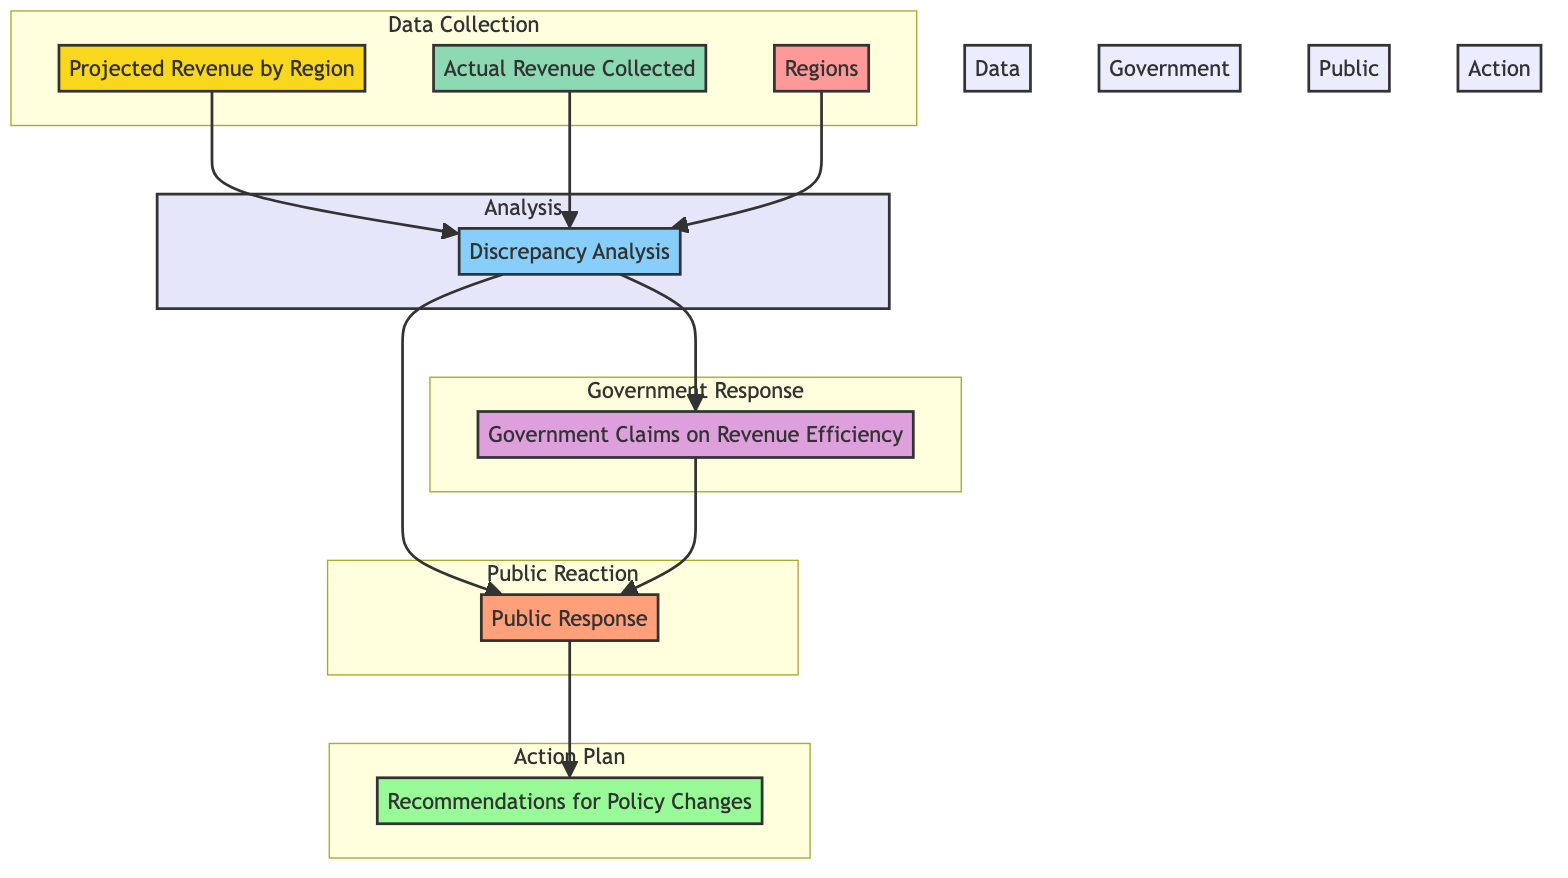What are the two types of revenue figures presented in the diagram? The diagram mentions "Projected Revenue by Region" and "Actual Revenue Collected." Both types provide information about tax revenue figures but are based on different timeframes—projected figures are estimates, while actual figures reflect what was collected after the fiscal year.
Answer: Projected Revenue by Region, Actual Revenue Collected How many regions are considered in the analysis of tax revenue? The diagram identifies that the "Regions" element is used in the revenue comparison without specifying the exact number. However, typically, there are four regions mentioned: Northeast, Southeast, Midwest, and West, comprising a general structure for regional analysis.
Answer: Four What is the main purpose of the Discrepancy Analysis process? The "Discrepancy Analysis" evaluates the differences between projected and actual revenues, highlighting inconsistencies that might indicate inefficiencies in revenue collection as claimed by the government.
Answer: Highlight inconsistencies Which element feeds into both "Government Claims on Revenue Efficiency" and "Public Response"? The "Discrepancy Analysis" feeds into both nodes because it scrutinizes the differences in revenue, prompting government claims about efficiency and influencing public response to any discrepancies found.
Answer: Discrepancy Analysis What does the "Public Response" node indicate about community reactions? The "Public Response" node indicates the community's reaction, which can include aspects such as media coverage and public protests, reflecting how the public perceives the discrepancies between projected and actual revenue.
Answer: Community reaction What action follows after analyzing discrepancies and receiving public feedback? Following the analysis and public response, the next step is to provide "Recommendations for Policy Changes," which suggests modifications to improve tax collection methods based on the discrepancies identified and public feedback received.
Answer: Recommendations for Policy Changes What is the flow direction from the "Actual Revenue Collected" in the diagram? The "Actual Revenue Collected" flows into the "Discrepancy Analysis," indicating that the actual tax revenue collected is a part of the evaluation process that compares it against projected figures, leading to further analysis and outcomes.
Answer: Discrepancy Analysis 